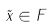Convert formula to latex. <formula><loc_0><loc_0><loc_500><loc_500>\tilde { x } \in F</formula> 